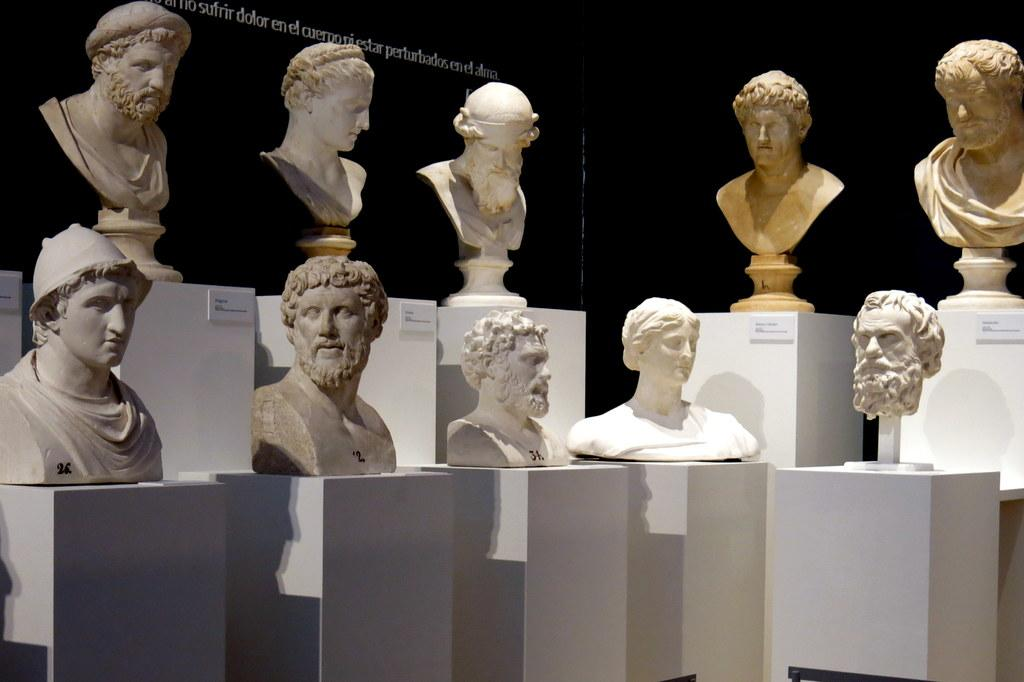What can be seen in the image? There are statues in the image. How are the statues positioned? The statues are on boxes. How can the statues be identified? The statues have name plates. What is the color of the background in the image? The background of the image is black. What type of island can be seen in the image? There is no island present in the image; it features statues on boxes with name plates against a black background. 